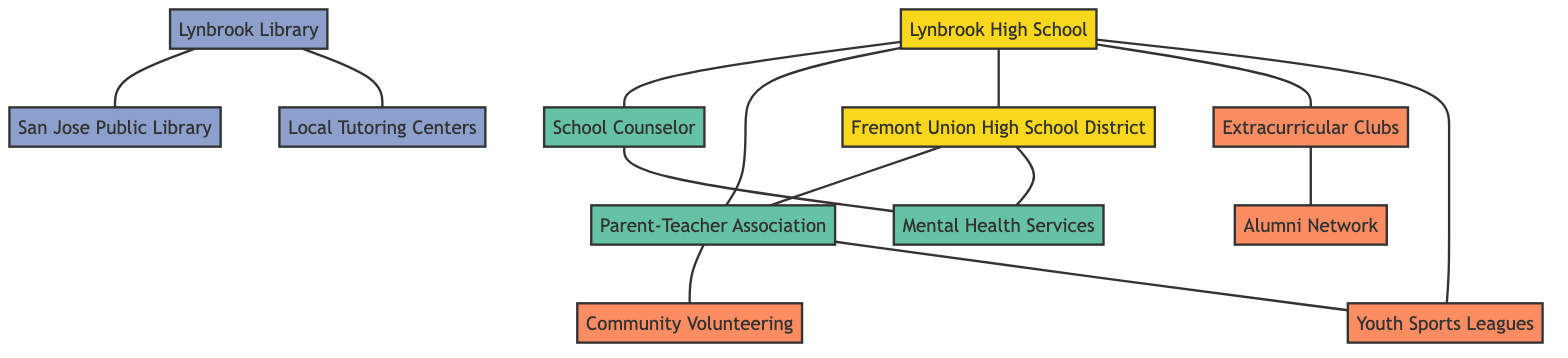What is the total number of nodes in the diagram? By reviewing the provided data, we can see that there are 12 defined nodes representing different resources and support networks.
Answer: 12 Which node represents the school district? The node labeled "Fremont Union High School District" represents the school district, as it directly connects to Lynbrook High School.
Answer: Fremont Union High School District How many edges connect to Lynbrook High School? Lynbrook High School is connected to 5 other nodes (School Counselor, Parent-Teacher Association, Fremont Union High School District, Extracurricular Clubs, and Youth Sports Leagues), which denotes 5 edges.
Answer: 5 Which resource is linked to the School Counselor? The School Counselor is linked to "Mental Health Services," indicating a direct relationship for student support.
Answer: Mental Health Services Which two nodes are connected by a direct edge besides Lynbrook High School? The edge between "Fremont Union High School District" and "Parent-Teacher Association" represents a direct connection that does not involve Lynbrook High School.
Answer: Fremont Union High School District and Parent-Teacher Association What type of resource is represented by the node "San Jose Public Library"? The "San Jose Public Library" is categorized as an academic resource, based on its characteristics in the diagram.
Answer: academic Which node is connected to both the Parent-Teacher Association and Community Volunteering Opportunities? The "Parent-Teacher Association" connects to "Community Volunteering Opportunities" and also to Lynbrook High School, creating a link between these two.
Answer: Parent-Teacher Association How many support nodes are present in the diagram? The diagram includes 4 support nodes: School Counselor, Parent-Teacher Association, Mental Health Services, and Alumni Network, providing various types of assistance.
Answer: 4 What is the relationship between Extracurricular Clubs and Alumni Network? "Extracurricular Clubs" has a direct edge connecting to "Alumni Network," indicating a connection or possible interaction between participants in those clubs and alumni.
Answer: connection 